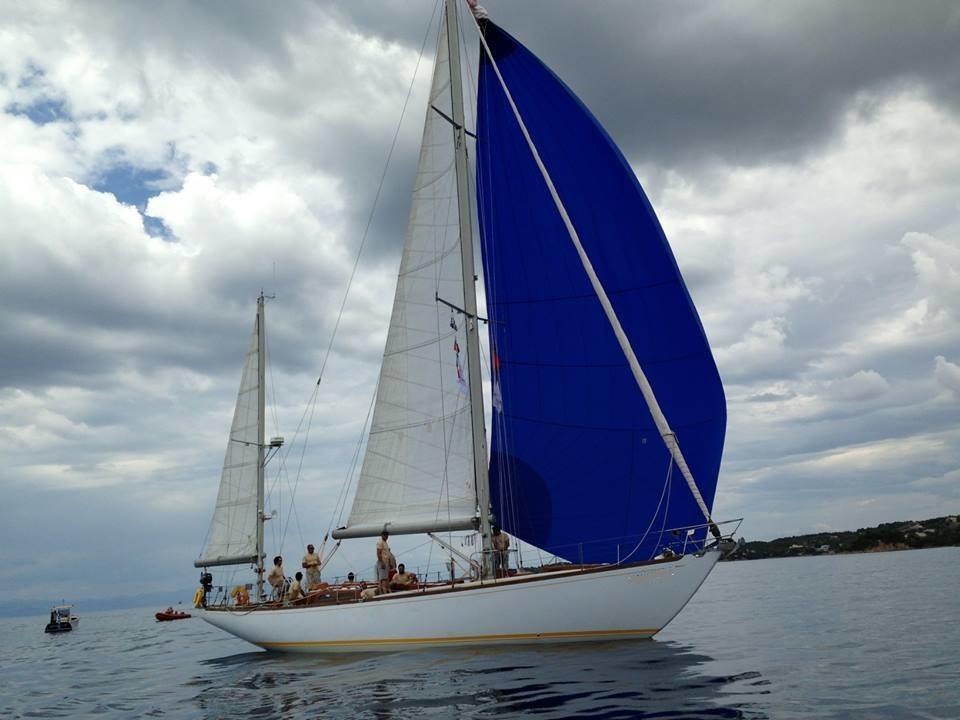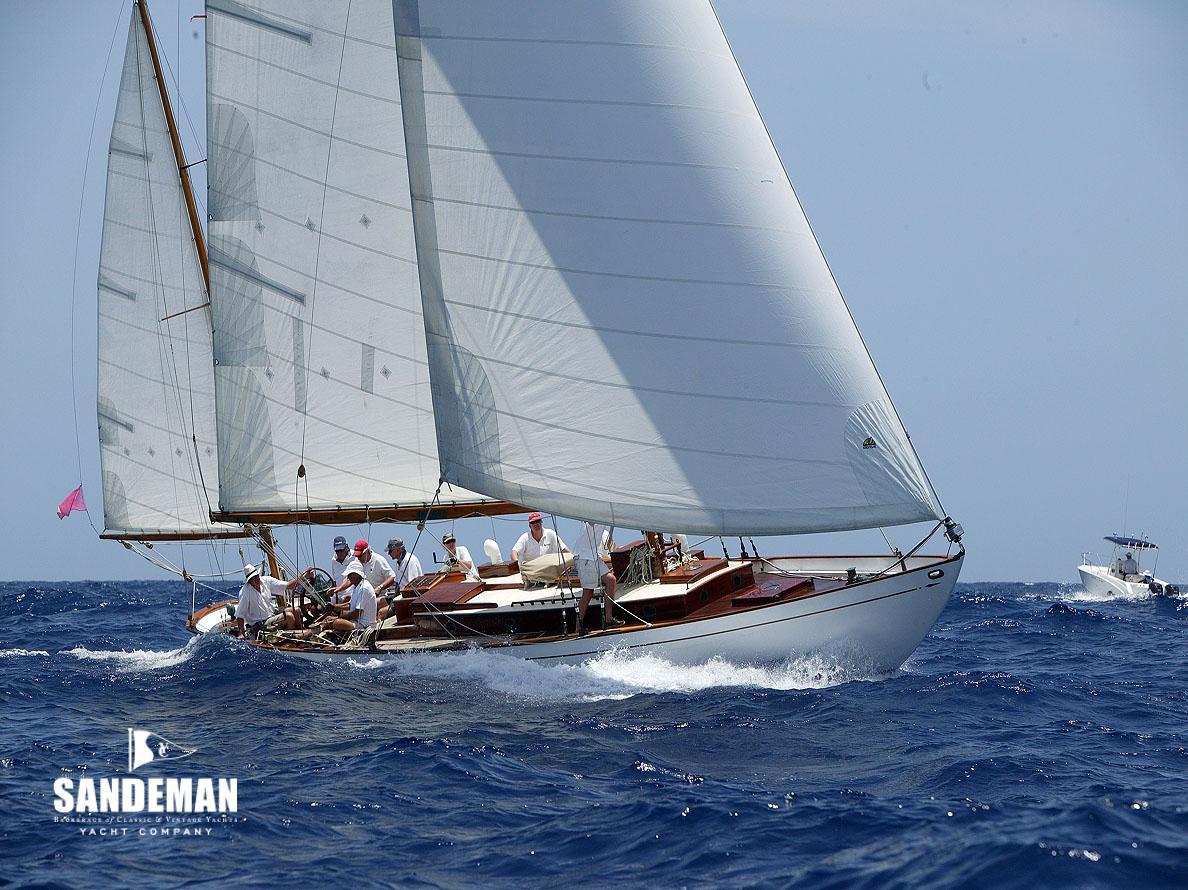The first image is the image on the left, the second image is the image on the right. Assess this claim about the two images: "An image shows a sailboat with a blue body creating white spray as it moves across the water.". Correct or not? Answer yes or no. No. 